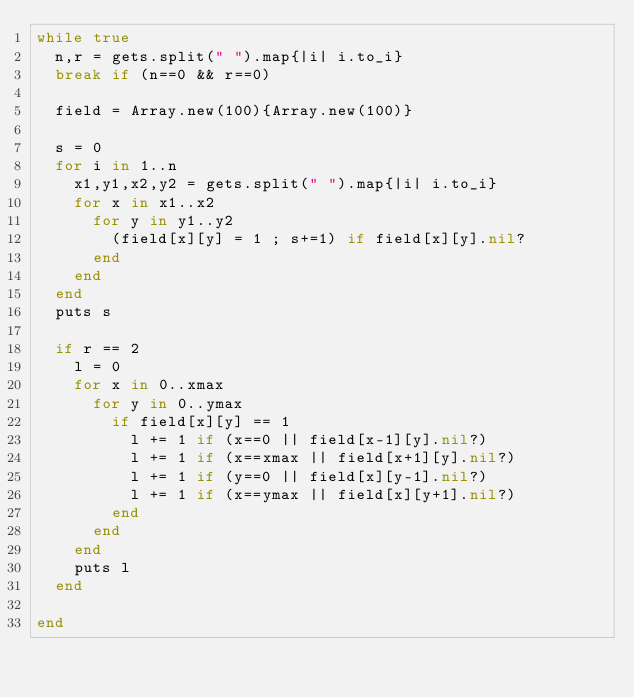<code> <loc_0><loc_0><loc_500><loc_500><_Ruby_>while true
  n,r = gets.split(" ").map{|i| i.to_i}
  break if (n==0 && r==0)
  
  field = Array.new(100){Array.new(100)}
  
  s = 0
  for i in 1..n
    x1,y1,x2,y2 = gets.split(" ").map{|i| i.to_i}  
    for x in x1..x2
      for y in y1..y2
        (field[x][y] = 1 ; s+=1) if field[x][y].nil?
      end
    end
  end
  puts s
  
  if r == 2
    l = 0
    for x in 0..xmax
      for y in 0..ymax
        if field[x][y] == 1
          l += 1 if (x==0 || field[x-1][y].nil?)
          l += 1 if (x==xmax || field[x+1][y].nil?)
          l += 1 if (y==0 || field[x][y-1].nil?)
          l += 1 if (x==ymax || field[x][y+1].nil?)
        end
      end
    end
    puts l
  end

end
          
  
  </code> 